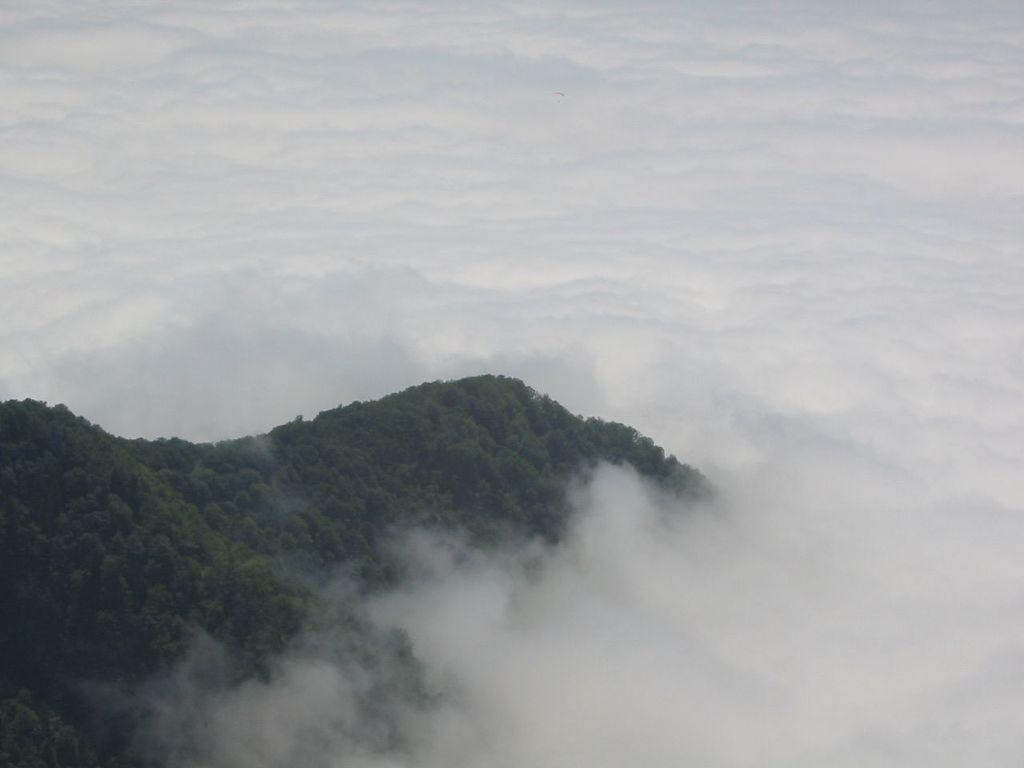What type of vegetation is present on the left side of the image? There are many trees on the left side of the image. What atmospheric condition can be observed in the image? There is mist visible in the image. What type of bells can be heard ringing in the wilderness in the image? There are no bells present in the image, and no sounds are mentioned. Additionally, the term "wilderness" is not mentioned in the provided facts. 